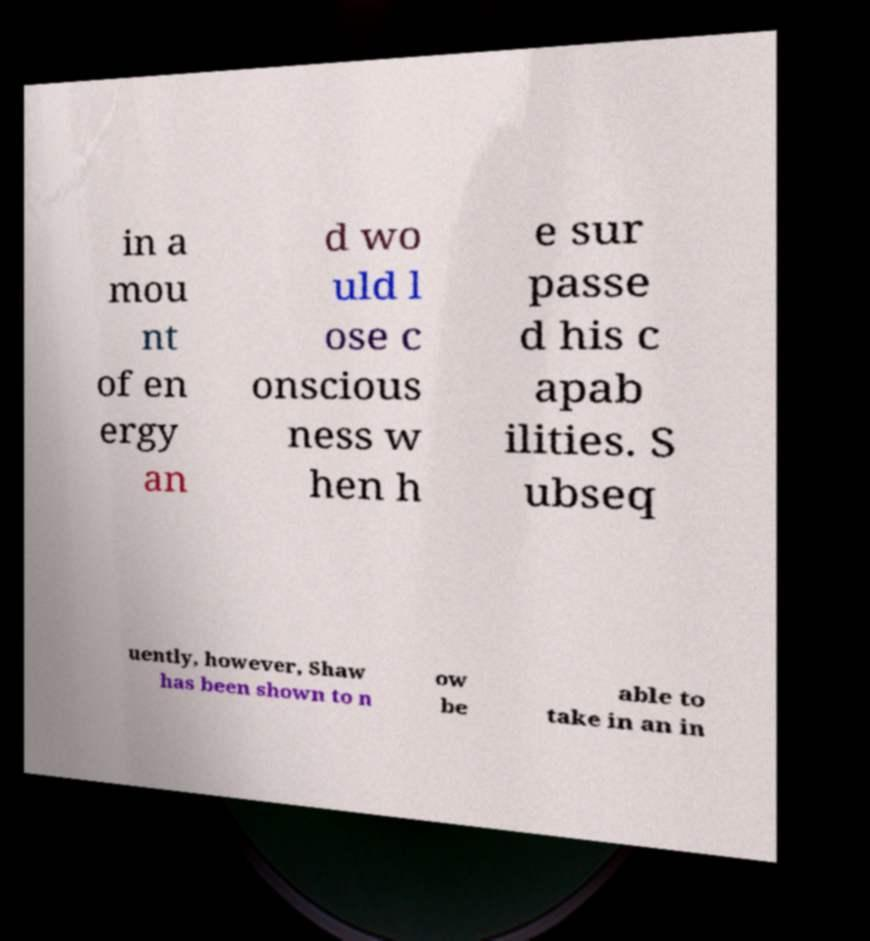Can you read and provide the text displayed in the image?This photo seems to have some interesting text. Can you extract and type it out for me? in a mou nt of en ergy an d wo uld l ose c onscious ness w hen h e sur passe d his c apab ilities. S ubseq uently, however, Shaw has been shown to n ow be able to take in an in 